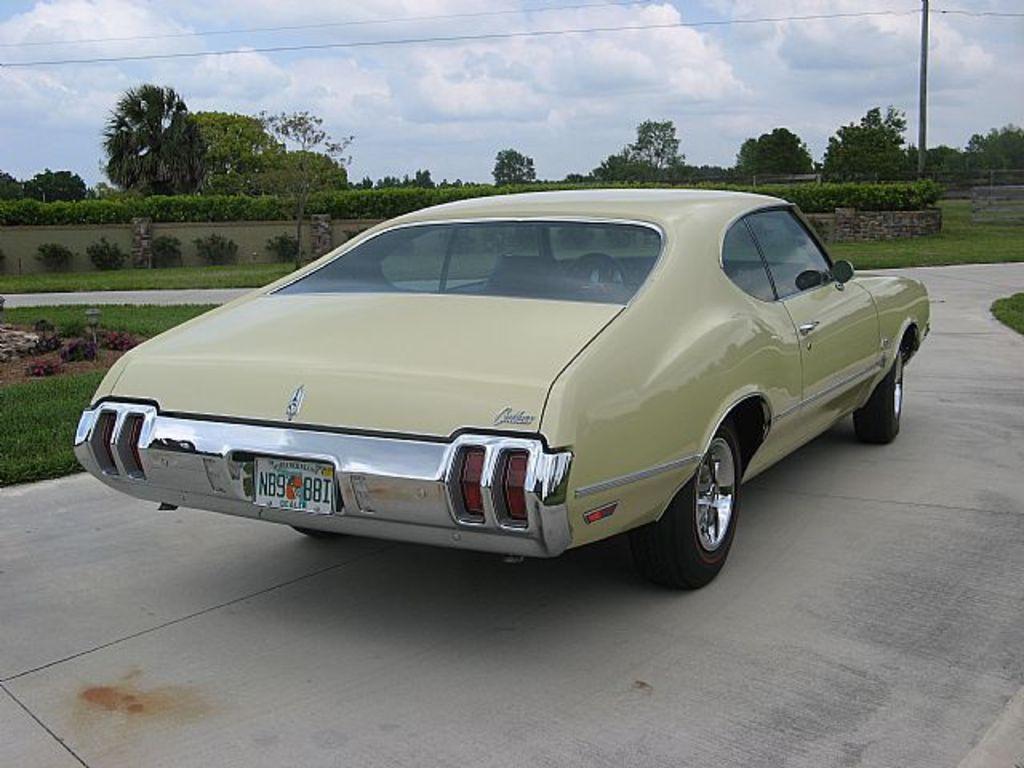Could you give a brief overview of what you see in this image? In this image there is a car on a road, in the background there is a grassland, plants, trees, poles and the sky. 